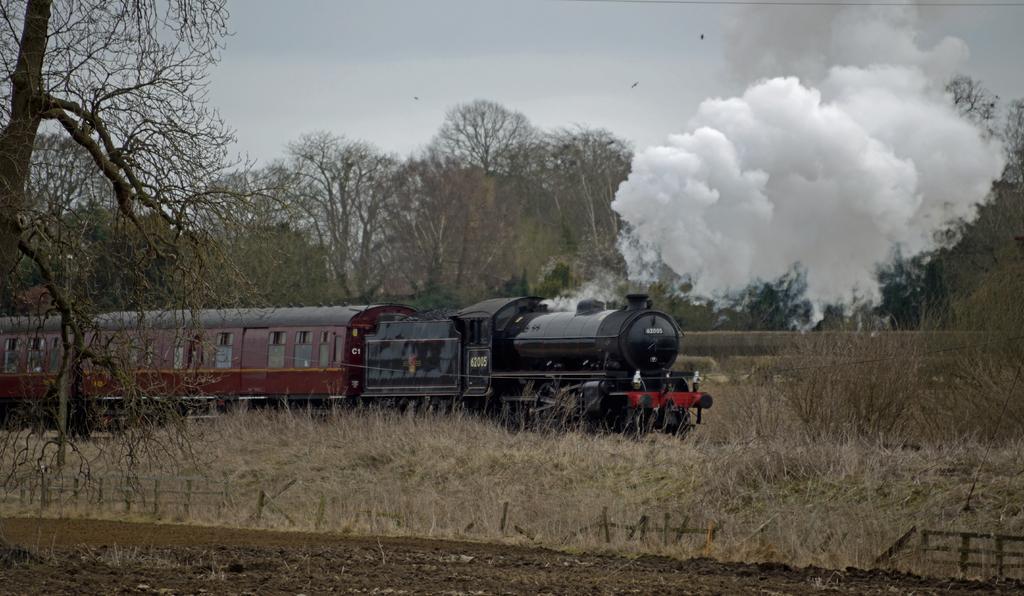Please provide a concise description of this image. In this picture there is a train on the railway track. Here we can see smoke which is coming from the engine. On the bottom we can see wooden fencing and grass. In the background we can see many trees. At the top we can see sky and clouds. Here we can see birds which are flying in the sky. 